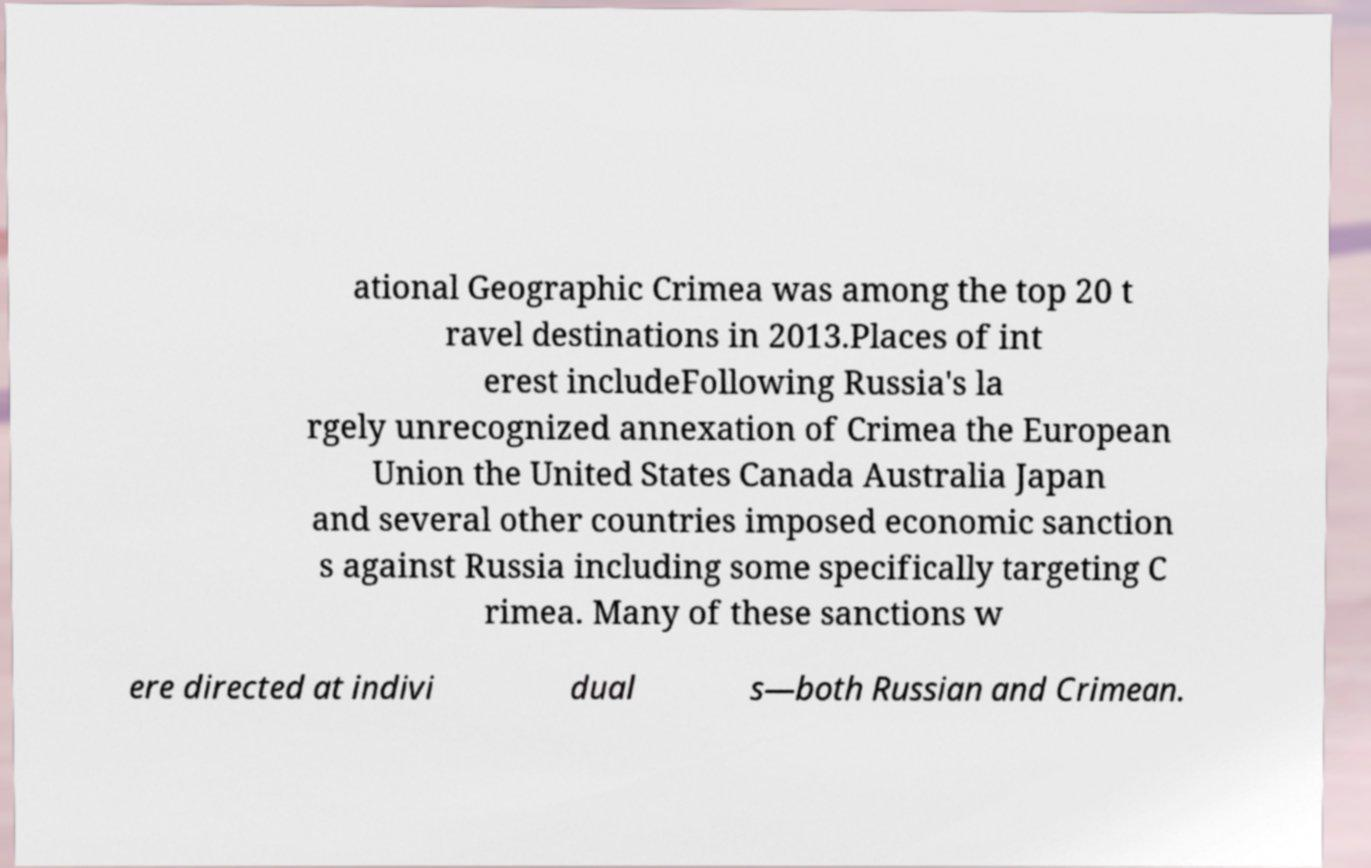Can you accurately transcribe the text from the provided image for me? ational Geographic Crimea was among the top 20 t ravel destinations in 2013.Places of int erest includeFollowing Russia's la rgely unrecognized annexation of Crimea the European Union the United States Canada Australia Japan and several other countries imposed economic sanction s against Russia including some specifically targeting C rimea. Many of these sanctions w ere directed at indivi dual s—both Russian and Crimean. 